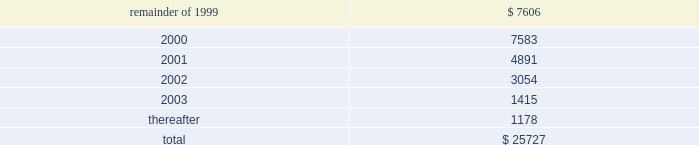The containerboard group ( a division of tenneco packaging inc. ) notes to combined financial statements ( continued ) april 11 , 1999 14 .
Leases ( continued ) to the sale transaction on april 12 , 1999 .
Therefore , the remaining outstanding aggregate minimum rental commitments under noncancelable operating leases are as follows : ( in thousands ) .
15 .
Sale of assets in the second quarter of 1996 , packaging entered into an agreement to form a joint venture with caraustar industries whereby packaging sold its two recycled paperboard mills and a fiber recycling operation and brokerage business to the joint venture in return for cash and a 20% ( 20 % ) equity interest in the joint venture .
Proceeds from the sale were approximately $ 115 million and the group recognized a $ 50 million pretax gain ( $ 30 million after taxes ) in the second quarter of 1996 .
In june , 1998 , packaging sold its remaining 20% ( 20 % ) equity interest in the joint venture to caraustar industries for cash and a note of $ 26000000 .
The group recognized a $ 15 million pretax gain on this transaction .
At april 11 , 1999 , the balance of the note with accrued interest is $ 27122000 .
The note was paid in june , 1999 .
16 .
Subsequent events on august 25 , 1999 , pca and packaging agreed that the acquisition consideration should be reduced as a result of a postclosing price adjustment by an amount equal to $ 20 million plus interest through the date of payment by packaging .
The group recorded $ 11.9 million of this amount as part of the impairment charge on the accompanying financial statements , representing the amount that was previously estimated by packaging .
Pca intends to record the remaining amount in september , 1999 .
In august , 1999 , pca signed purchase and sales agreements with various buyers to sell approximately 405000 acres of timberland .
Pca has completed the sale of approximately 260000 of these acres and expects to complete the sale of the remaining acres by mid-november , 1999. .
What percentage of outstanding aggregate minimum rental commitments under noncancelable operating leases are due after 2003? 
Computations: (1178 / 25727)
Answer: 0.04579. 